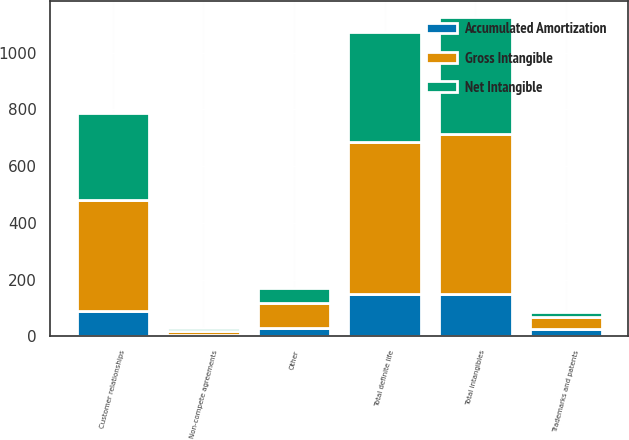Convert chart. <chart><loc_0><loc_0><loc_500><loc_500><stacked_bar_chart><ecel><fcel>Customer relationships<fcel>Trademarks and patents<fcel>Non-compete agreements<fcel>Other<fcel>Total definite life<fcel>Total intangibles<nl><fcel>Gross Intangible<fcel>393<fcel>43<fcel>14<fcel>86<fcel>536<fcel>563<nl><fcel>Accumulated Amortization<fcel>89<fcel>25<fcel>6<fcel>30<fcel>150<fcel>150<nl><fcel>Net Intangible<fcel>304<fcel>18<fcel>8<fcel>56<fcel>386<fcel>413<nl></chart> 